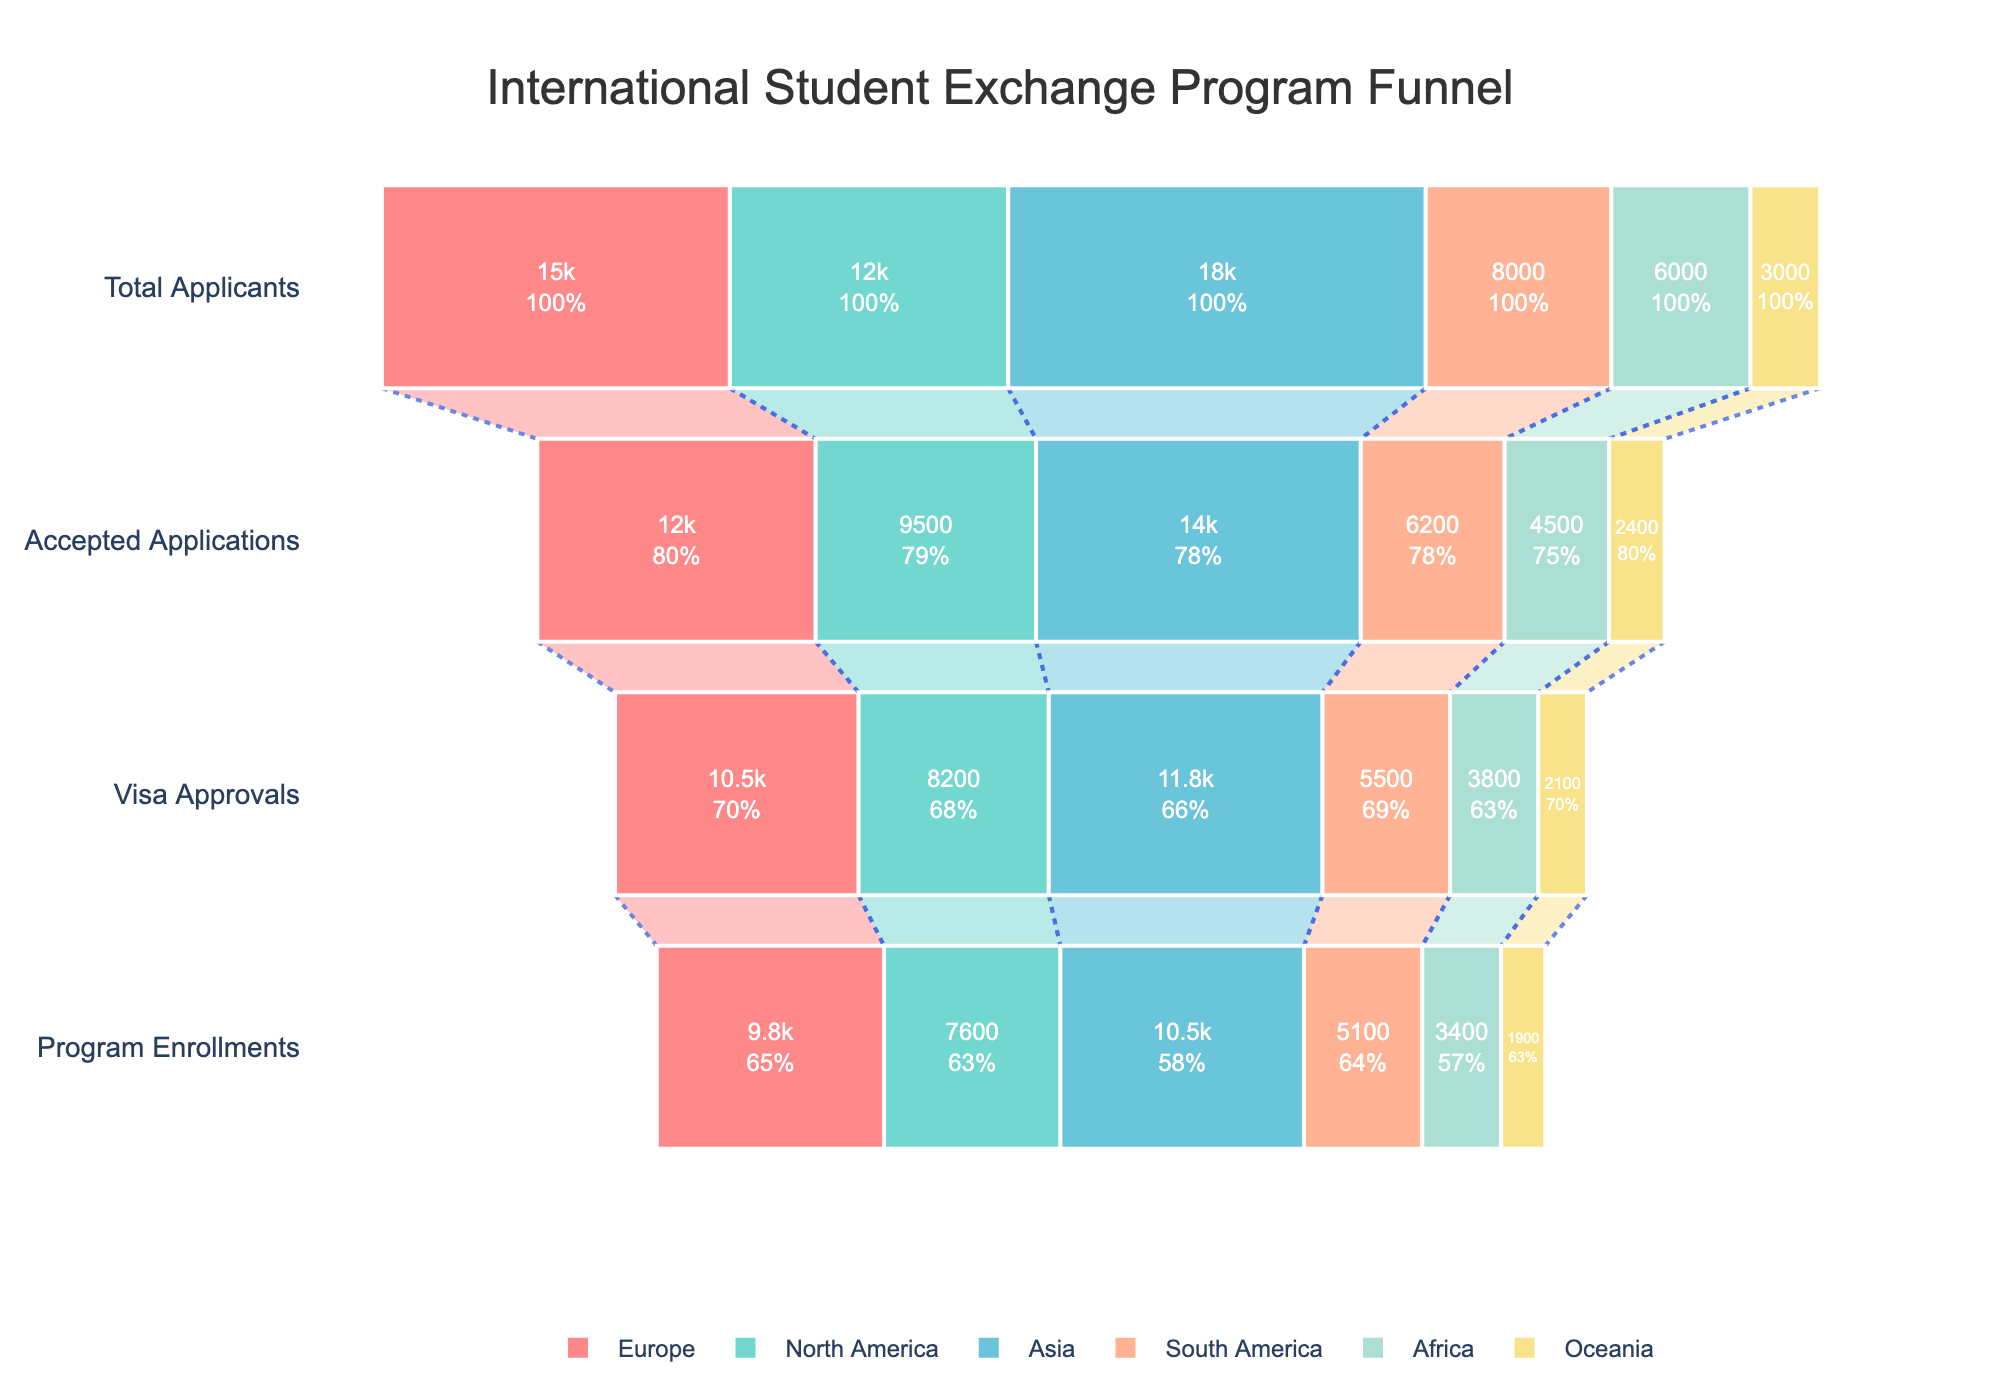What is the title of the funnel chart? The title of the funnel chart is located at the top center and reads, "International Student Exchange Program Funnel".
Answer: International Student Exchange Program Funnel How many regions are displayed in the funnel chart? There are six regions represented in the chart. Each region has its own sequence of funnel stages, indicated by different colored layers.
Answer: Six Which region has the highest number of total applicants? Look at the values for "Total Applicants" for each region, and identify the highest number. Asia has the highest number, which is 18,000.
Answer: Asia Compare the number of accepted applications between Europe and South America. Europe has 12,000 accepted applications and South America has 6,200. Therefore, Europe has more accepted applications.
Answer: Europe What is the difference in program enrollments between North America and Oceania? North America has 7,600 enrollments and Oceania has 1,900. The difference is 7,600 - 1,900 = 5,700 enrollments.
Answer: 5,700 Which stage sees the largest drop-off for Africa? Look at the values for Africa at each stage. The largest drop-off occurs between Total Applicants (6,000) and Accepted Applications (4,500), a difference of 1,500.
Answer: Total Applicants to Accepted Applications What is the average number of visa approvals across all regions? Sum the visa approvals for all regions (10,500 + 8,200 + 11,800 + 5,500 + 3,800 + 2,100 = 41,900) and divide by the number of regions (6). The average is 41,900 / 6 ≈ 6,983.33.
Answer: 6,983.33 Which region has the highest rate of conversion from visa approvals to program enrollments? Calculate the conversion rate for each region by dividing the number of program enrollments by the number of visa approvals. Determine which region has the highest percentage.
Answer: Europe What percentage of applicants become program enrollees for Asia? Divide the number of enrollments (10,500) by the total number of applicants (18,000) and multiply by 100. (10,500 / 18,000) * 100 ≈ 58.33%.
Answer: 58.33% How does the total number of applicants for Africa compare to that of Oceania? Africa has 6,000 applicants while Oceania has 3,000, showing that Africa has double the number of applicants compared to Oceania.
Answer: Africa has double 